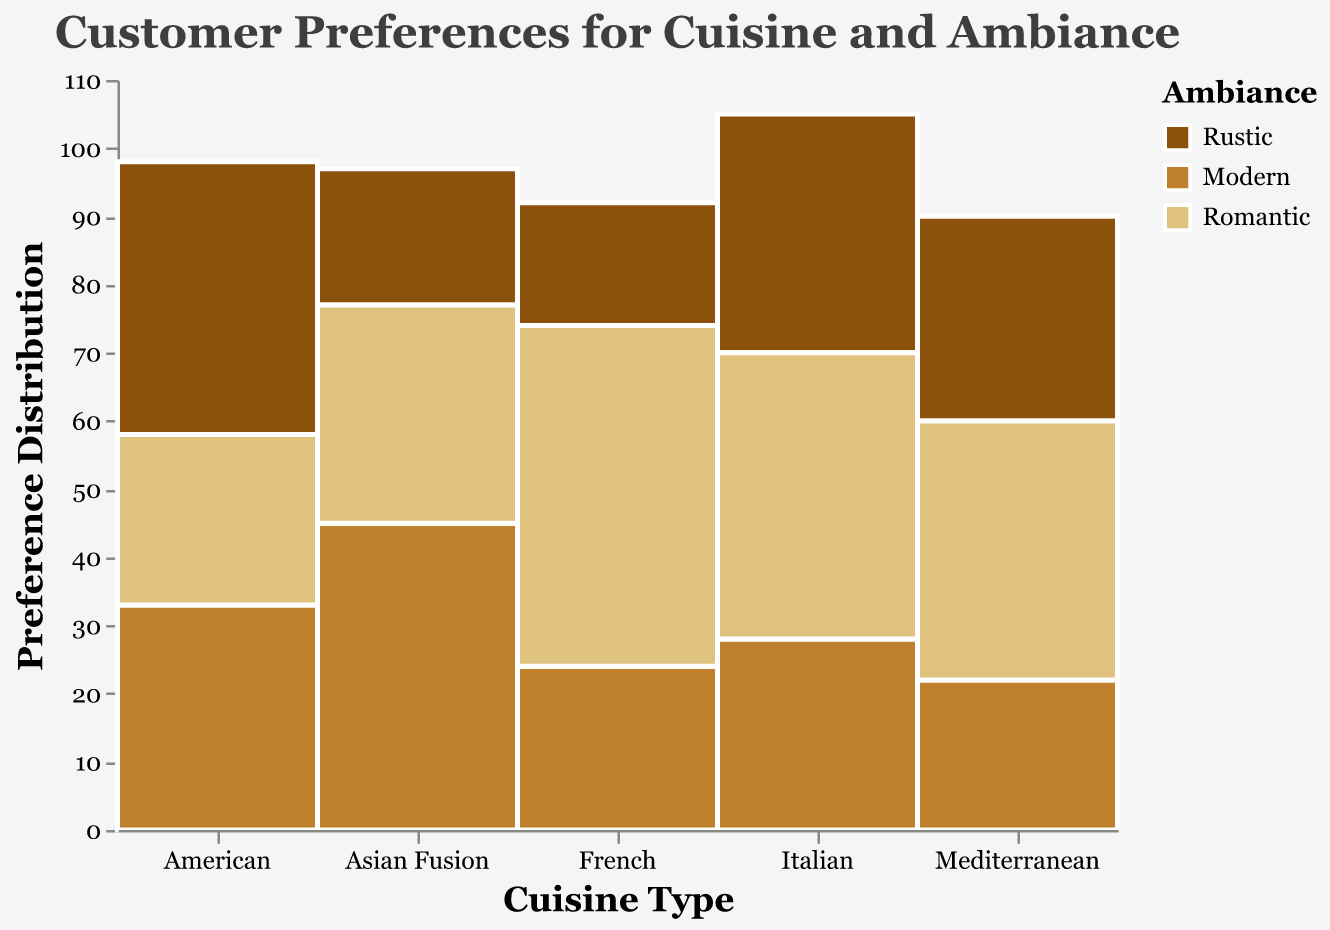Which Cuisine has the highest preference for the Romantic ambiance? Italian, Mediterranean, American, Asian Fusion, and French have Romantic ambiance percentages of 42, 38, 25, 32, and 50 respectively. The highest among these is 50 for French.
Answer: French Which ambiance does Italian cuisine have the lowest preference for? Looking at the bars for Italian cuisine, the values for Rustic, Modern, and Romantic are 35, 28, and 42 respectively. The lowest value is 28 for Modern.
Answer: Modern What is the total preference for Asian Fusion cuisine across all ambiances? Adding the preferences for Rustic, Modern, and Romantic ambiances in Asian Fusion cuisine: 20 + 45 + 32 = 97.
Answer: 97 Compare the preference for Rustic ambiance between American and Mediterranean cuisines. Which one is higher? American and Mediterranean preferences for Rustic vibes are 40 and 30 respectively. 40 is greater than 30. Therefore, American cuisine has a higher preference.
Answer: American Which cuisine has the largest variation in preferences among different ambiances? Calculate the range for each cuisine by finding the difference between the highest and lowest preference values. Italian: 42 - 28 = 14, Mediterranean: 38 - 22 = 16, American: 40 - 25 = 15, Asian Fusion: 45 - 20 = 25, and French: 50 - 18 = 32. The largest variation is for French cuisine with a range of 32.
Answer: French Identify the ambiance that has the highest preference within the Mediterranean cuisine. The preferences for Mediterranean cuisine are Rustic: 30, Modern: 22, and Romantic: 38. The highest value among these is 38 for Romantic.
Answer: Romantic Which ambiance has more preference, Italian Rustic or French Modern? Italian Rustic has a preference value of 35, and French Modern has a value of 24. Comparing these, 35 is greater than 24. Italian Rustic has more preference.
Answer: Italian Rustic What is the overall distribution of preferences for the Modern ambiance? By looking at each cuisine's Modern ambiance preferences and converting their segments into percentages relative to the whole cuisine preference:
- Italian (28/105) ≈ 26.7%
- Mediterranean (22/90) ≈ 24.4%
- American (33/98) ≈ 33.7%
- Asian Fusion (45/97) ≈ 46.4%
- French (24/92) ≈ 26.1%
The overall distribution would reflect these values in the Modern segments in the mosaic plot.
Answer: About 25-50% per cuisine Which cuisine has the smallest overall preference? Summing the preferences for each cuisine:
- Italian: 35 + 28 + 42 = 105
- Mediterranean: 30 + 22 + 38 = 90
- American: 40 + 33 + 25 = 98
- Asian Fusion: 20 + 45 + 32 = 97
- French: 18 + 24 + 50 = 92
The smallest total is for Mediterranean cuisine with 90.
Answer: Mediterranean For American cuisine, rank the ambiances from most to least preferred. Preferences for American cuisine are Rustic: 40, Modern: 33, and Romantic: 25. Ranking them: Rustic > Modern > Romantic.
Answer: Rustic > Modern > Romantic 